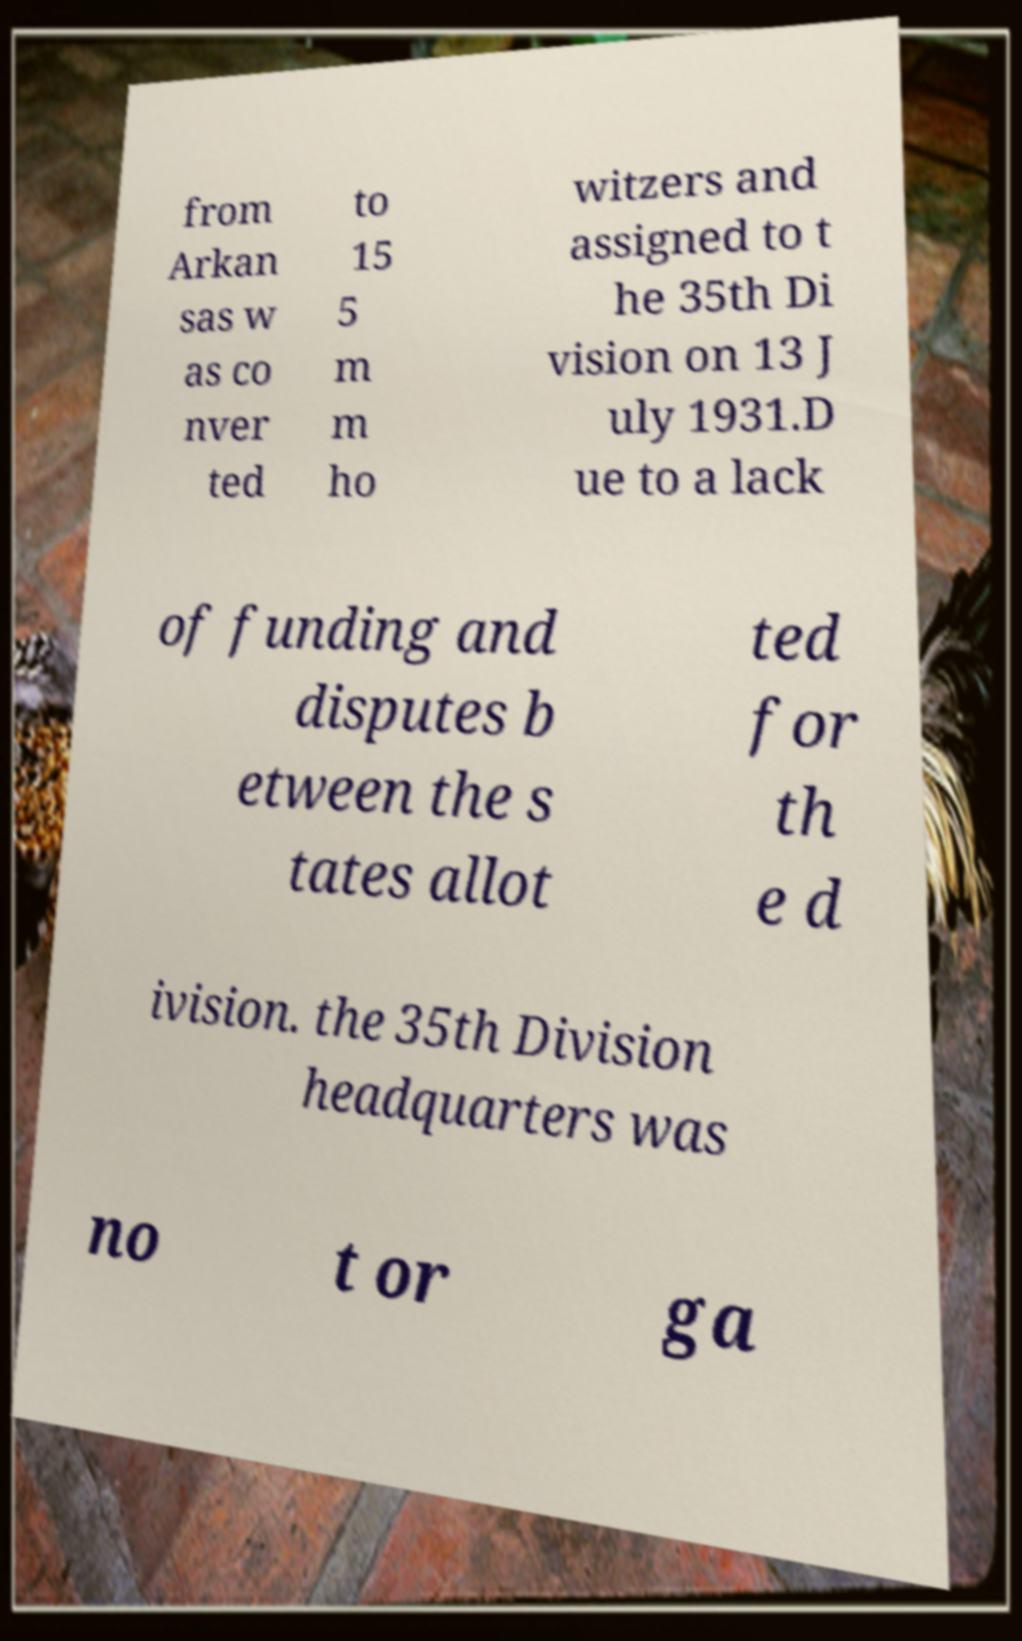Can you read and provide the text displayed in the image?This photo seems to have some interesting text. Can you extract and type it out for me? from Arkan sas w as co nver ted to 15 5 m m ho witzers and assigned to t he 35th Di vision on 13 J uly 1931.D ue to a lack of funding and disputes b etween the s tates allot ted for th e d ivision. the 35th Division headquarters was no t or ga 